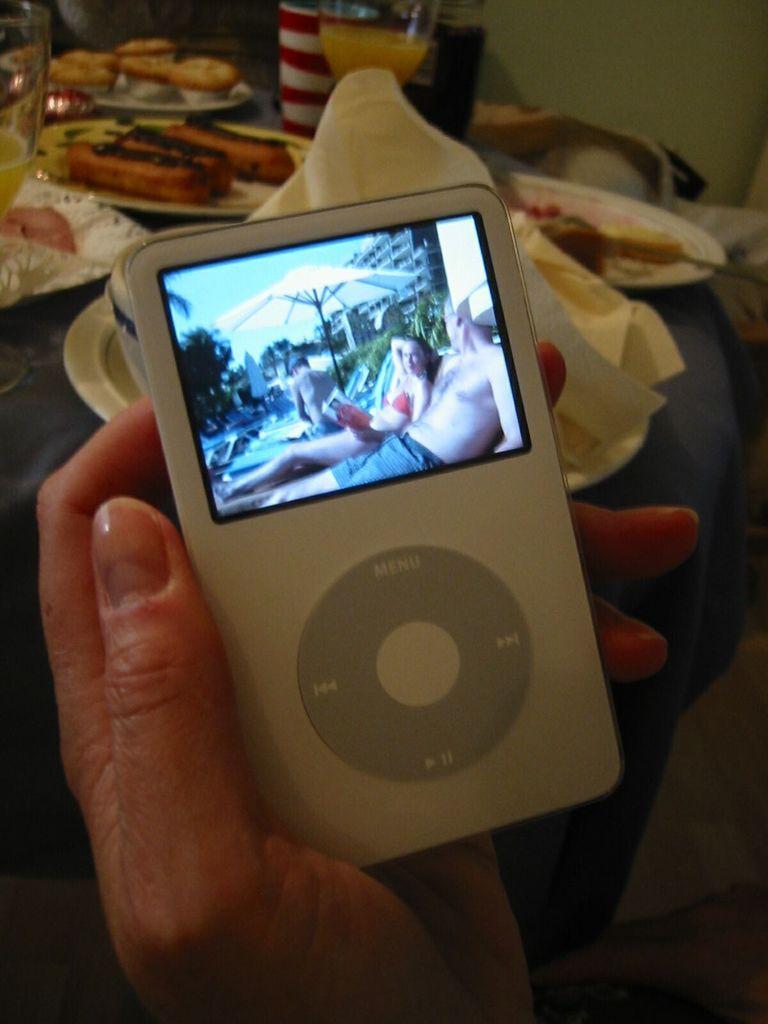How would you summarize this image in a sentence or two? In this image I can see the person holding an electronic device. In-front of the person I can see the plates with food and the glasses with drink in it. These are on the surface. 